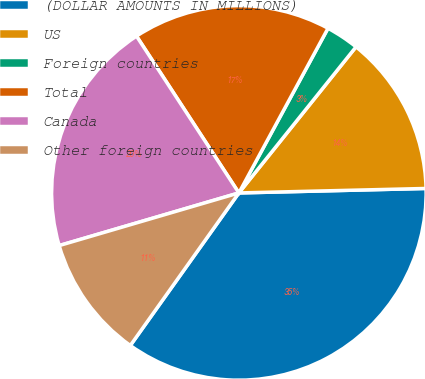Convert chart. <chart><loc_0><loc_0><loc_500><loc_500><pie_chart><fcel>(DOLLAR AMOUNTS IN MILLIONS)<fcel>US<fcel>Foreign countries<fcel>Total<fcel>Canada<fcel>Other foreign countries<nl><fcel>35.22%<fcel>13.86%<fcel>2.86%<fcel>17.1%<fcel>20.33%<fcel>10.62%<nl></chart> 